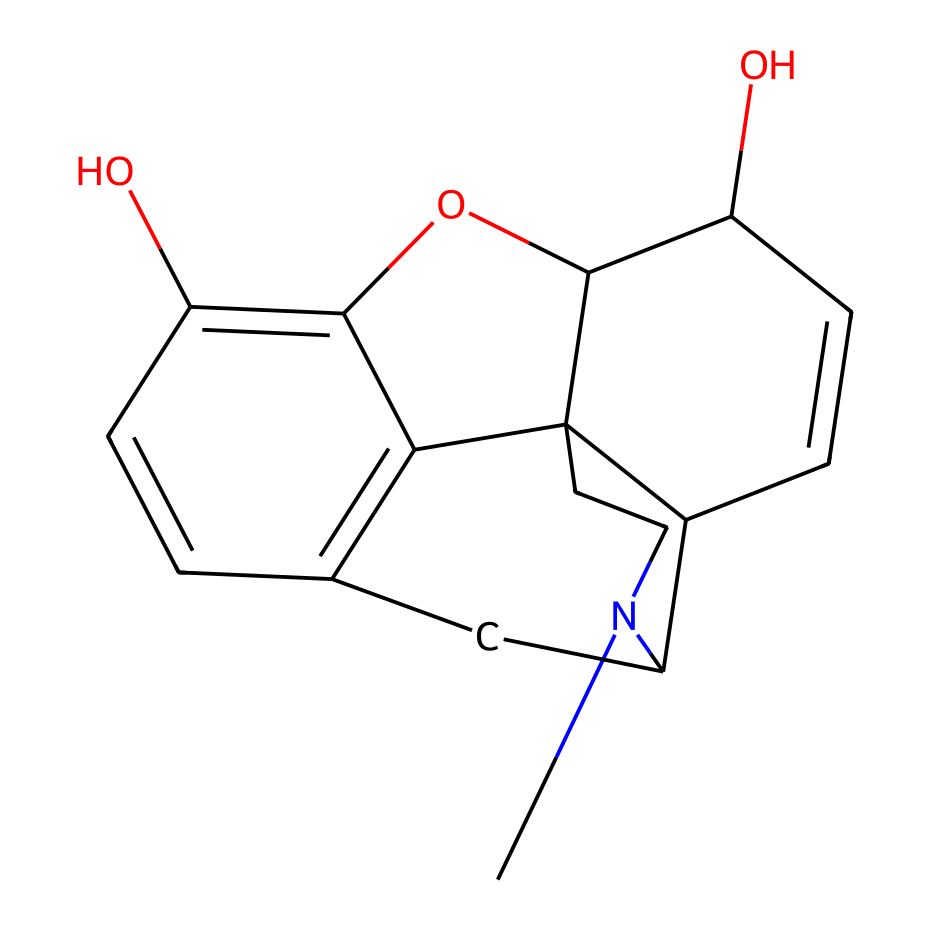What alkaloid is represented by this structure? The structure corresponds to morphine, which is a well-known alkaloid derived from the opium poppy. It is frequently studied for its analgesic properties.
Answer: morphine How many carbon atoms are present in the structure? By analyzing the SMILES representation, we can count the carbon atoms systematically. The structure includes a total of 17 carbon atoms, as derived from the visual representation of the structure.
Answer: 17 How many hydroxyl (–OH) groups are in this structure? The SMILES reveals two instances of oxygen atoms connected to hydrogen, indicating the presence of two hydroxyl groups in the morphine structure, which contribute to its solubility.
Answer: 2 What type of bonds predominantly exist in this alkaloid? Reviewing the SMILES, we can observe that morphine primarily contains single bonds, with some double bonds in the cyclic structure, highlighting its complex arrangement.
Answer: single and double Which functional group defines this compound as an alkaloid? The presence of a nitrogen atom in the structure indicates that morphine possesses the characteristic amine functional group, which is typical for alkaloids.
Answer: amine What is the degree of saturation of the morphine structure? By analyzing the number of rings and multiple bonds in the chemical structure noted in the SMILES, morphine is determined to have a high degree of saturation with multiple cycles and substituents.
Answer: high What is the primary action of morphine in medicinal use? Morphine's action is primarily as a pain reliever; it interacts with specific receptors in the brain to alleviate pain, making it highly valued in medicine.
Answer: analgesic 